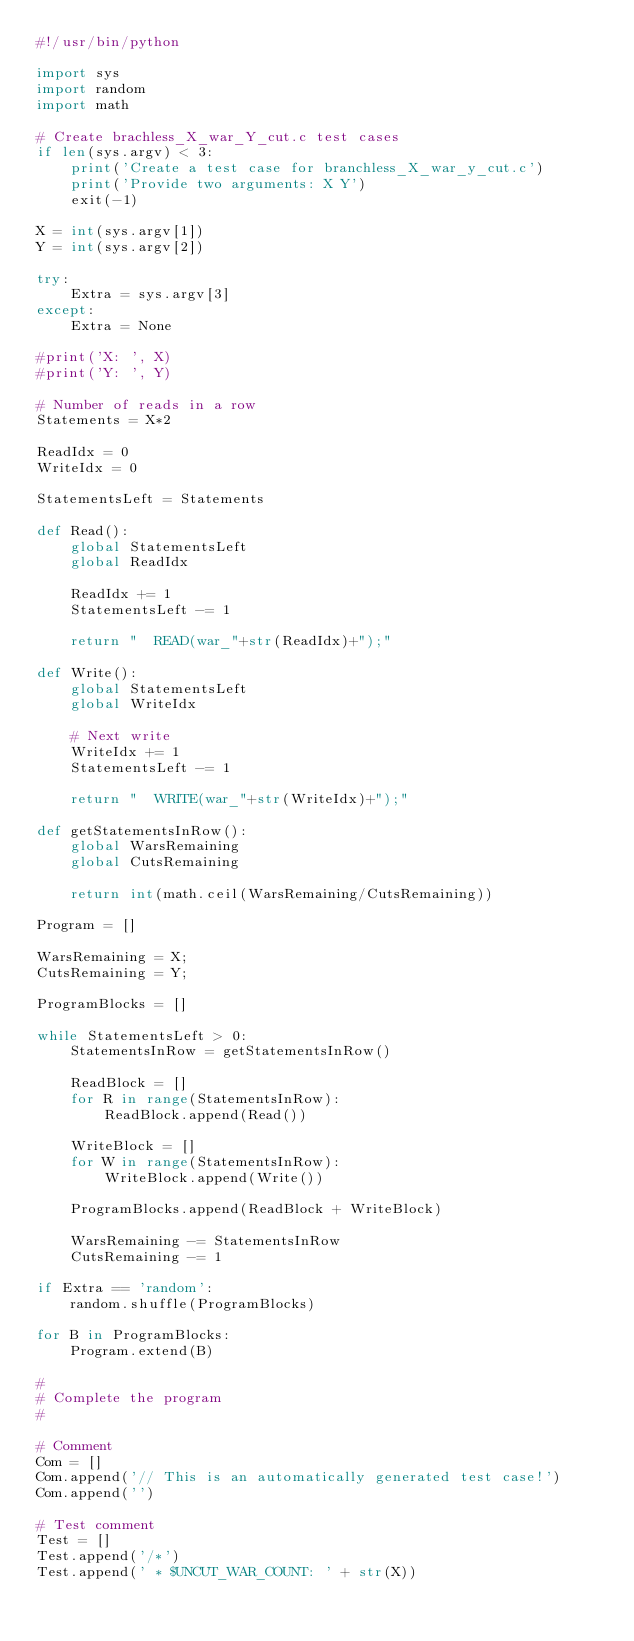<code> <loc_0><loc_0><loc_500><loc_500><_Python_>#!/usr/bin/python

import sys
import random
import math

# Create brachless_X_war_Y_cut.c test cases
if len(sys.argv) < 3:
    print('Create a test case for branchless_X_war_y_cut.c')
    print('Provide two arguments: X Y')
    exit(-1)

X = int(sys.argv[1])
Y = int(sys.argv[2])

try:
    Extra = sys.argv[3]
except:
    Extra = None

#print('X: ', X)
#print('Y: ', Y)

# Number of reads in a row
Statements = X*2

ReadIdx = 0
WriteIdx = 0

StatementsLeft = Statements

def Read():
    global StatementsLeft
    global ReadIdx

    ReadIdx += 1
    StatementsLeft -= 1

    return "  READ(war_"+str(ReadIdx)+");"

def Write():
    global StatementsLeft
    global WriteIdx

    # Next write
    WriteIdx += 1
    StatementsLeft -= 1

    return "  WRITE(war_"+str(WriteIdx)+");"

def getStatementsInRow():
    global WarsRemaining
    global CutsRemaining

    return int(math.ceil(WarsRemaining/CutsRemaining))

Program = []

WarsRemaining = X;
CutsRemaining = Y;

ProgramBlocks = []

while StatementsLeft > 0:
    StatementsInRow = getStatementsInRow()

    ReadBlock = []
    for R in range(StatementsInRow):
        ReadBlock.append(Read())

    WriteBlock = []
    for W in range(StatementsInRow):
        WriteBlock.append(Write())

    ProgramBlocks.append(ReadBlock + WriteBlock)

    WarsRemaining -= StatementsInRow
    CutsRemaining -= 1

if Extra == 'random':
    random.shuffle(ProgramBlocks)

for B in ProgramBlocks:
    Program.extend(B)

#
# Complete the program
#

# Comment
Com = []
Com.append('// This is an automatically generated test case!')
Com.append('')

# Test comment
Test = []
Test.append('/*')
Test.append(' * $UNCUT_WAR_COUNT: ' + str(X))</code> 